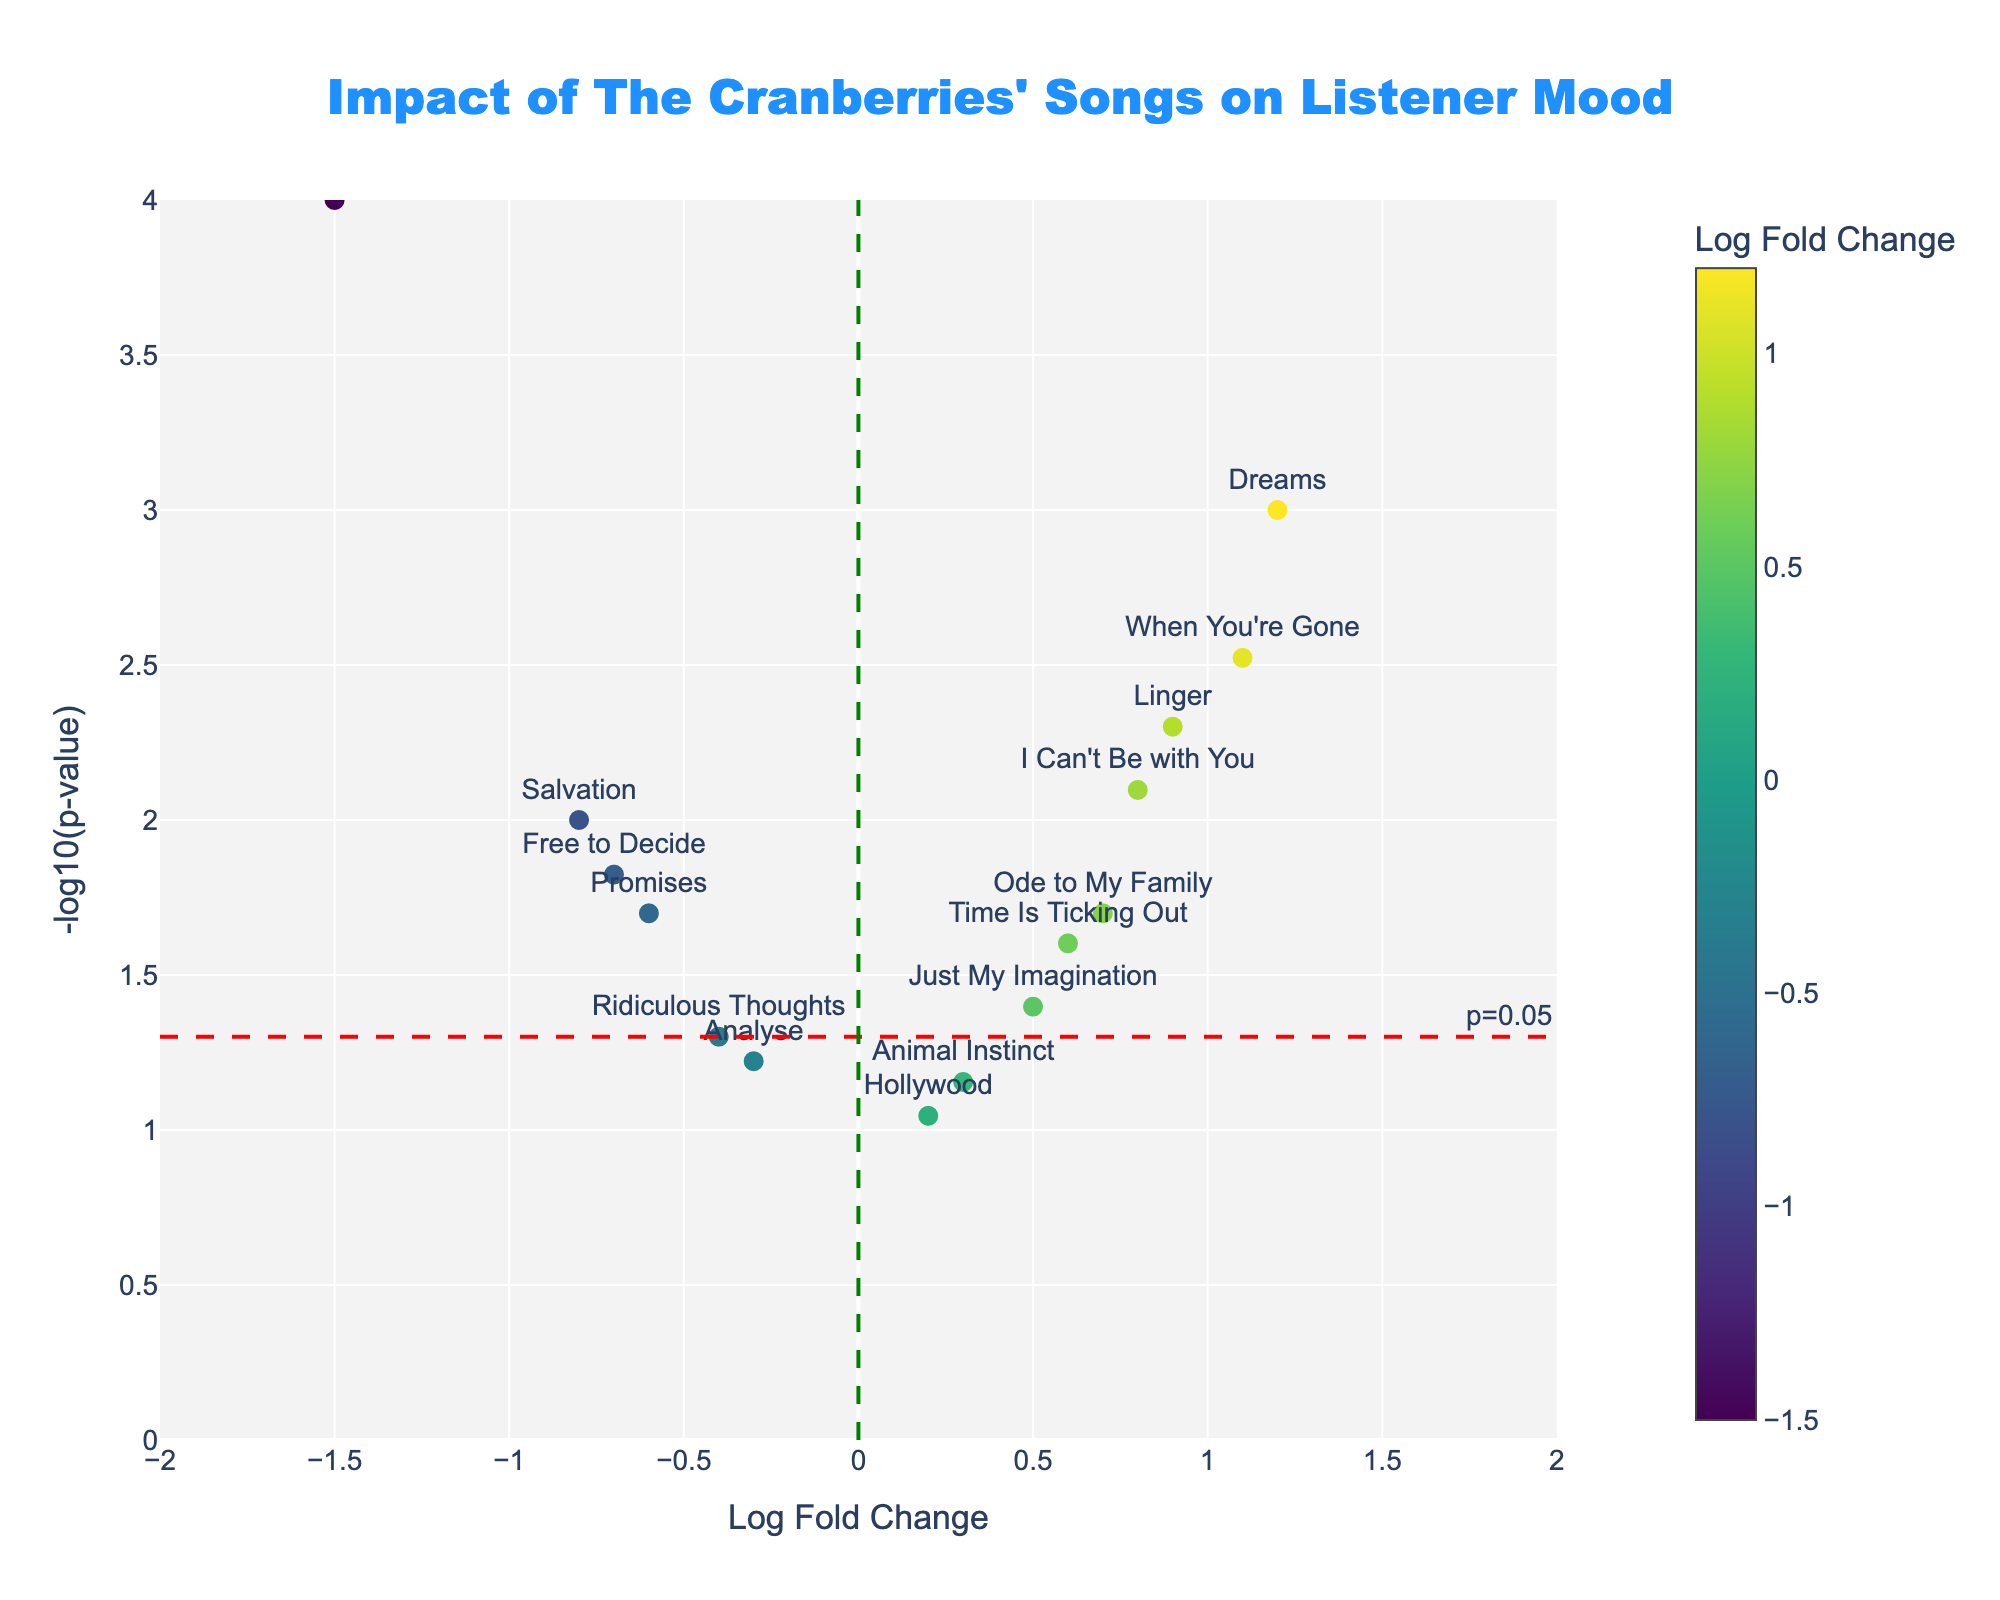what is the title of the plot? The title is usually located at the top of the plot and is used to give a brief idea about the content of the plot. In this case, the title should reflect the theme related to the impact of The Cranberries' songs on listener mood.
Answer: "Impact of The Cranberries' Songs on Listener Mood" what do the axes represent on the plot? Axes labels help identify what each axis represents. Here, the x-axis typically shows Log Fold Change, which in this context might quantify lyrical sentiment, and the y-axis shows -log10(p-value), which typically indicates the statistical significance of the data points.
Answer: The x-axis represents Log Fold Change and the y-axis represents -log10(p-value) how many songs are plotted on this graph? To determine the number of songs, you can count the number of data points (markers) on the plot. Each marker represents one song.
Answer: 15 songs which song has the highest -log10(p-value)? To find the highest -log10(p-value), locate the data point that is the highest on the y-axis. The text label associated with this point indicates the song.
Answer: "Zombie" is the Log Fold Change greater for "Dreams" or "When You're Gone"? Check the positions of the "Dreams" and "When You're Gone" data points on the x-axis, which represents Log Fold Change. Compare the x-axis values associated with these points.
Answer: "Dreams" which songs have a positive Log Fold Change and a p-value of less than 0.05? To answer this, find the data points to the right of the vertical line at x=0 (positive Log Fold Change) and above the horizontal line at y=-log10(0.05) (p-value < 0.05). Check the text labels of these data points.
Answer: "Dreams", "Linger", "When You're Gone", "I Can't Be with You" are there more songs with a positive or negative Log Fold Change? Count the number of data points to the right of the vertical line at x=0 (positive) and to the left of the vertical line at x=0 (negative). Compare the counts.
Answer: More songs have a positive Log Fold Change which song has the lowest Log Fold Change? Identify the data point furthest to the left on the x-axis, which represents the Log Fold Change. The associated text label indicates the song.
Answer: "Zombie" how many songs have a p-value greater than 0.05? Identify data points below the horizontal line at y=-log10(0.05). Count these data points to find how many have p-values greater than 0.05.
Answer: 5 songs 